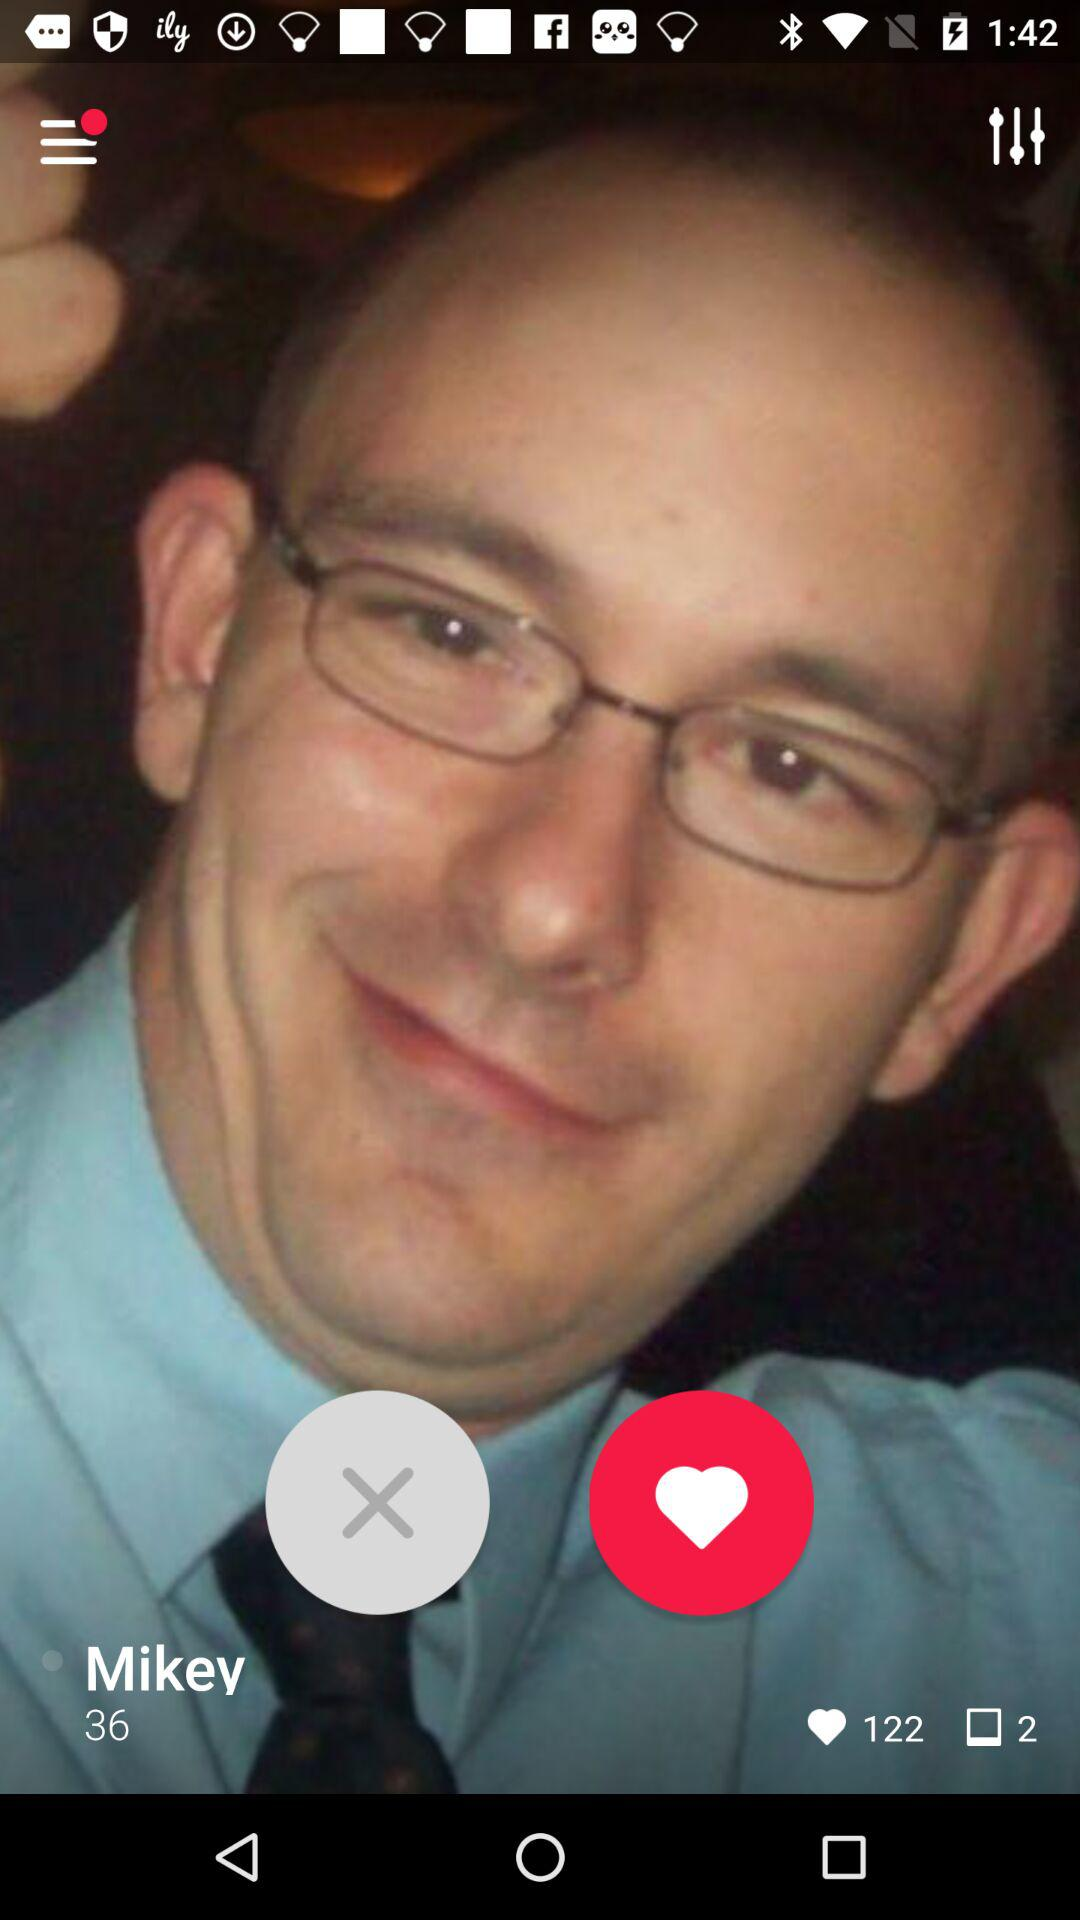How many likes are there? There are 122 likes. 